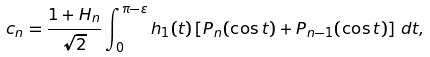Convert formula to latex. <formula><loc_0><loc_0><loc_500><loc_500>c _ { n } = \frac { 1 + H _ { n } } { \sqrt { 2 } } \int _ { 0 } ^ { \pi - \varepsilon } h _ { 1 } ( t ) \left [ P _ { n } ( \cos t ) + P _ { n - 1 } ( \cos t ) \right ] \, d t ,</formula> 